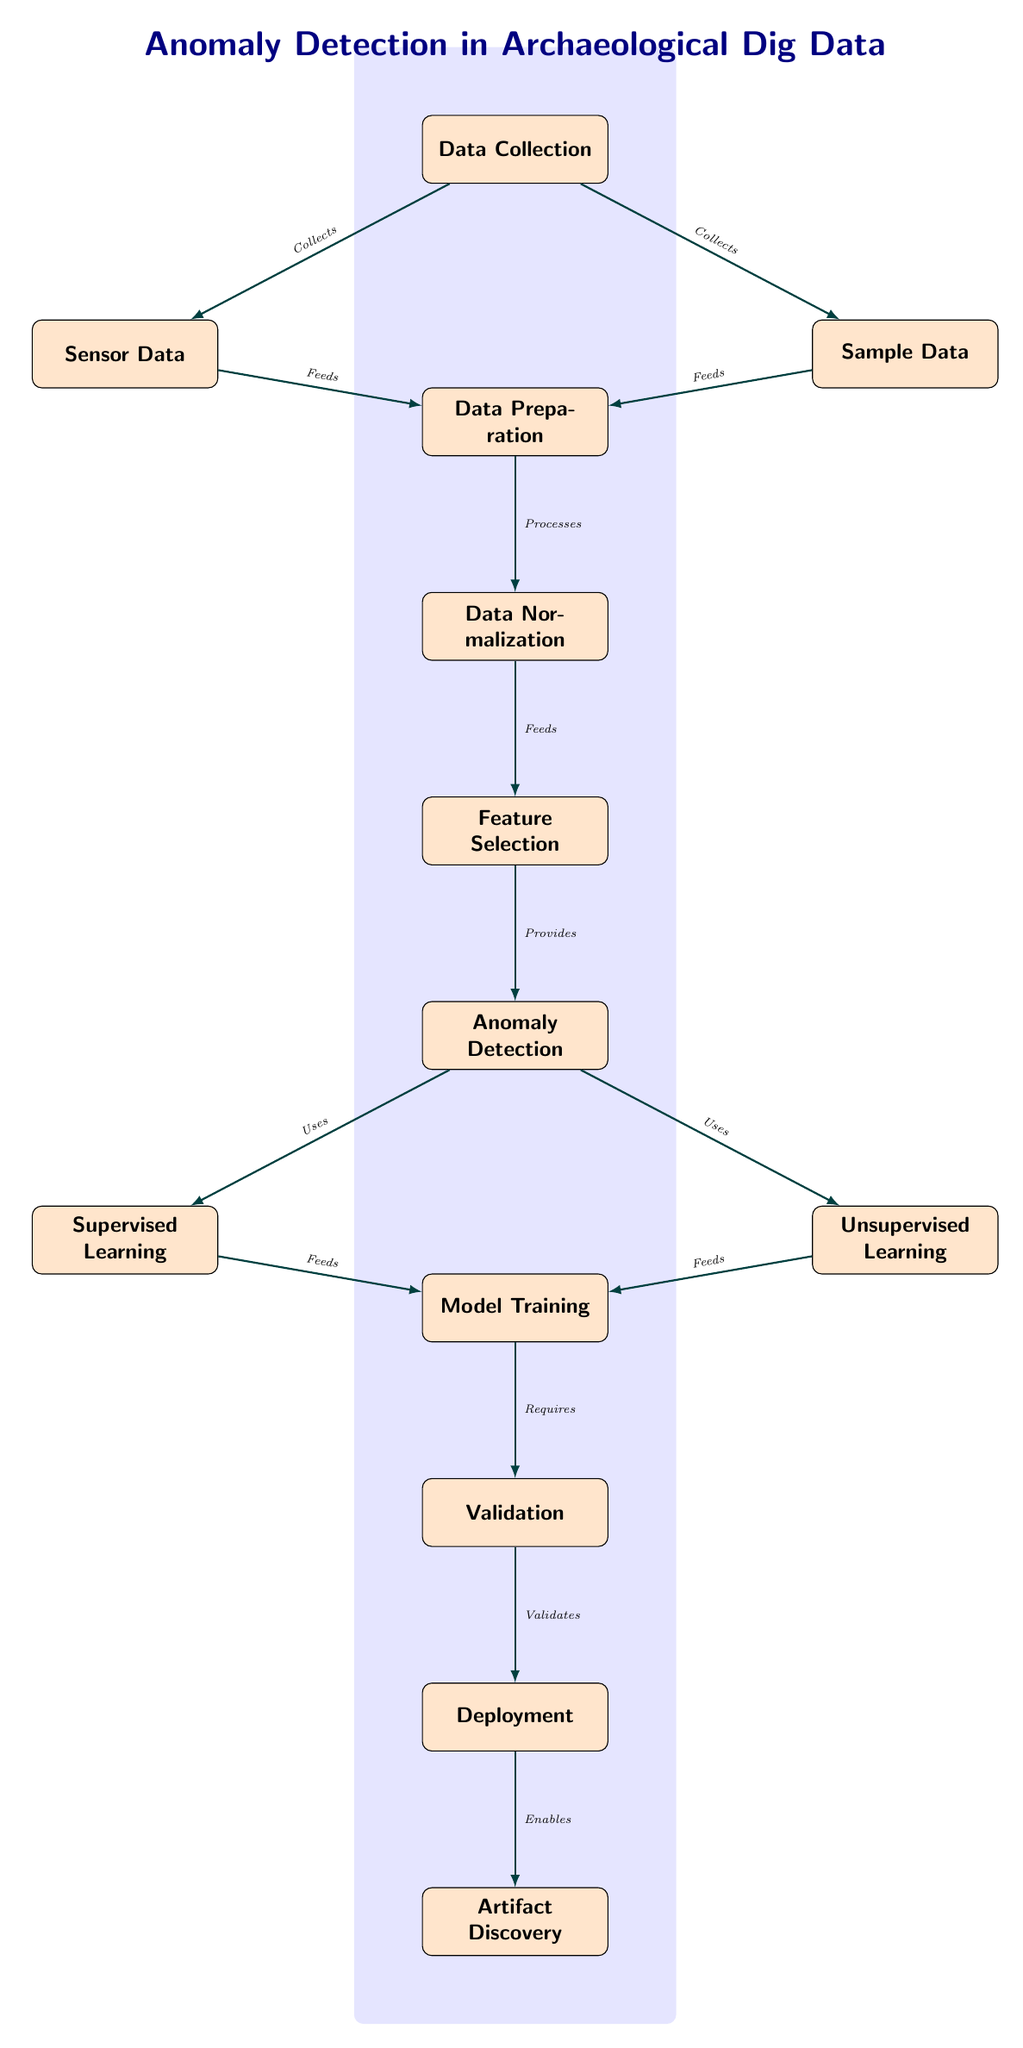What is the first node in the diagram? The first node in the diagram is labeled "Data Collection", which is positioned at the top of the structure.
Answer: Data Collection How many nodes are involved in the "Anomaly Detection" process? The "Anomaly Detection" process involves three nodes: it receives inputs from "Feature Selection", and it utilizes "Supervised Learning" and "Unsupervised Learning" which are directly below it.
Answer: Three What does "Data Preparation" process after "Data Collection"? After "Data Collection", the data flows to "Data Preparation", which is directly below it and is the next stage of the process as indicated by the arrow connection.
Answer: Data Preparation Which nodes contribute data to "Data Preparation"? The nodes that contribute data to "Data Preparation" are "Sensor Data" and "Sample Data". These are both positioned below the "Data Collection" node and are connected with arrows to "Data Preparation".
Answer: Sensor Data and Sample Data What is the last step in the anomaly detection process? The last step in the anomaly detection process is "Artifact Discovery", which is the final node at the bottom of the diagram, following the "Deployment" phase.
Answer: Artifact Discovery Which node uses both types of learning? The node labeled "Anomaly Detection" uses both types of learning as indicated by its connections to "Supervised Learning" and "Unsupervised Learning".
Answer: Anomaly Detection What does "Model Training" require? "Model Training" requires "Validation" to proceed, as indicated by the arrow going from "Model Training" to "Validation".
Answer: Validation Which process enables "Artifact Discovery"? The process that enables "Artifact Discovery" is the "Deployment" phase, as indicated by the direct connection illustrated by an arrow between them.
Answer: Deployment How do "Supervised Learning" and "Unsupervised Learning" relate to "Model Training"? Both "Supervised Learning" and "Unsupervised Learning" feed into "Model Training", as shown by the arrows pointing from both of these nodes to "Model Training".
Answer: Feed into Model Training 